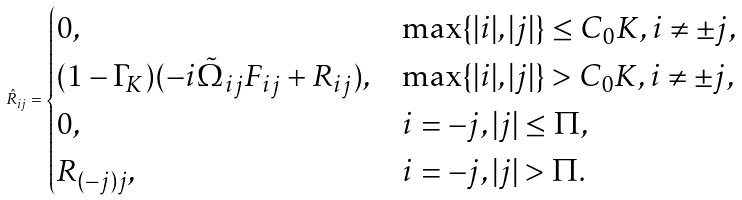<formula> <loc_0><loc_0><loc_500><loc_500>\hat { R } _ { i j } = \begin{cases} 0 , & \max \{ | i | , | j | \} \leq C _ { 0 } K , i \neq \pm j , \\ ( 1 - \Gamma _ { K } ) ( - i \tilde { \Omega } _ { i j } F _ { i j } + R _ { i j } ) , & \max \{ | i | , | j | \} > C _ { 0 } K , i \neq \pm j , \\ 0 , & i = - j , | j | \leq \Pi , \\ R _ { ( - j ) j } , & i = - j , | j | > \Pi . \end{cases}</formula> 